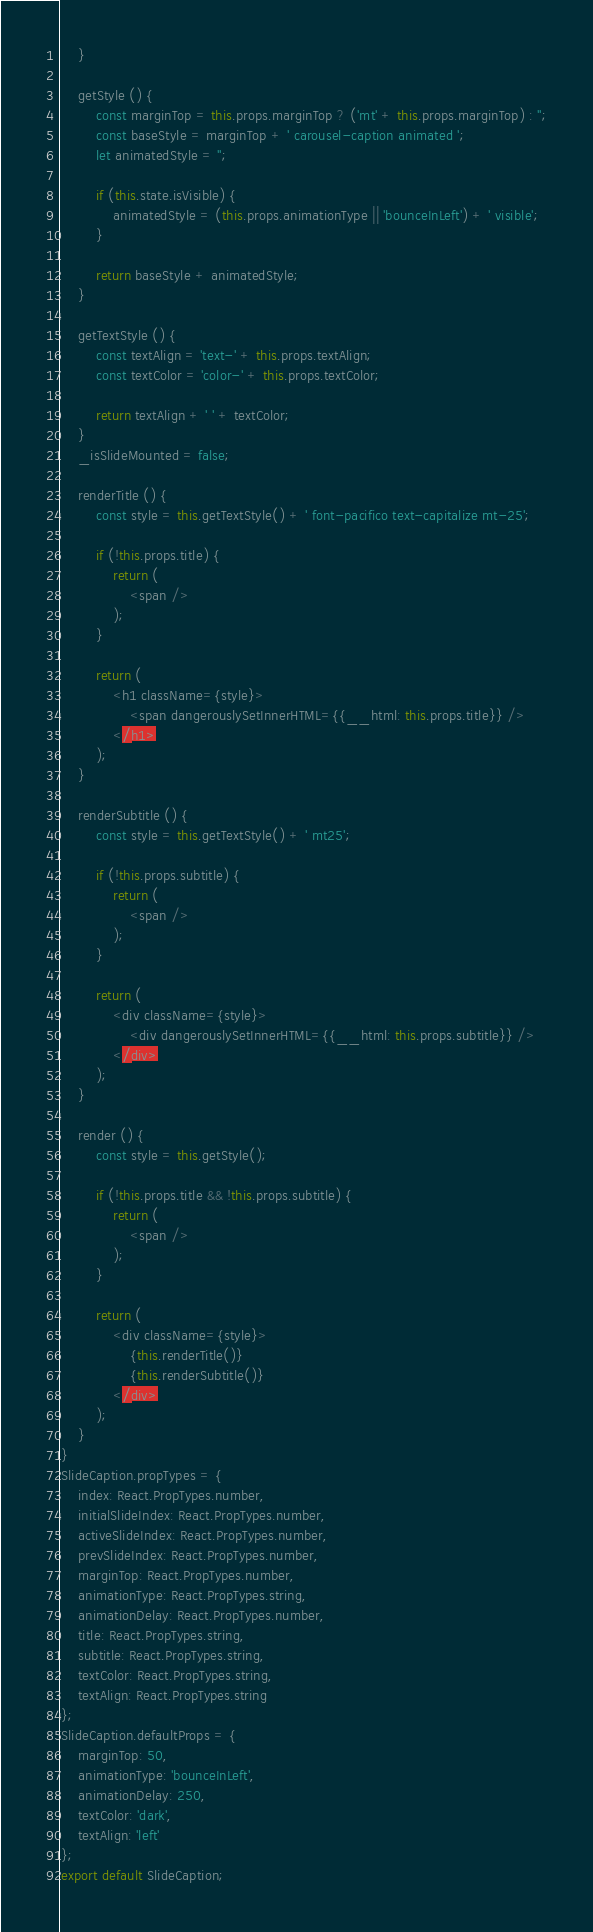<code> <loc_0><loc_0><loc_500><loc_500><_JavaScript_>	}

	getStyle () {
		const marginTop = this.props.marginTop ? ('mt' + this.props.marginTop) : '';
		const baseStyle = marginTop + ' carousel-caption animated ';
		let animatedStyle = '';

		if (this.state.isVisible) {
			animatedStyle = (this.props.animationType || 'bounceInLeft') + ' visible';
		}

		return baseStyle + animatedStyle;
	}

	getTextStyle () {
		const textAlign = 'text-' + this.props.textAlign;
		const textColor = 'color-' + this.props.textColor;

		return textAlign + ' ' + textColor;
	}
	_isSlideMounted = false;

	renderTitle () {
		const style = this.getTextStyle() + ' font-pacifico text-capitalize mt-25';

		if (!this.props.title) {
			return (
				<span />
			);
		}

		return (
			<h1 className={style}>
				<span dangerouslySetInnerHTML={{__html: this.props.title}} />
			</h1>
		);
	}

	renderSubtitle () {
		const style = this.getTextStyle() + ' mt25';

		if (!this.props.subtitle) {
			return (
				<span />
			);
		}

		return (
			<div className={style}>
				<div dangerouslySetInnerHTML={{__html: this.props.subtitle}} />
			</div>
		);
	}

	render () {
		const style = this.getStyle();

		if (!this.props.title && !this.props.subtitle) {
			return (
				<span />
			);
		}

		return (
			<div className={style}>
				{this.renderTitle()}
				{this.renderSubtitle()}
			</div>
		);
	}
}
SlideCaption.propTypes = {
	index: React.PropTypes.number,
	initialSlideIndex: React.PropTypes.number,
	activeSlideIndex: React.PropTypes.number,
	prevSlideIndex: React.PropTypes.number,
	marginTop: React.PropTypes.number,
	animationType: React.PropTypes.string,
	animationDelay: React.PropTypes.number,
	title: React.PropTypes.string,
	subtitle: React.PropTypes.string,
	textColor: React.PropTypes.string,
	textAlign: React.PropTypes.string
};
SlideCaption.defaultProps = {
	marginTop: 50,
	animationType: 'bounceInLeft',
	animationDelay: 250,
	textColor: 'dark',
	textAlign: 'left'
};
export default SlideCaption;
</code> 